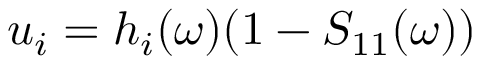Convert formula to latex. <formula><loc_0><loc_0><loc_500><loc_500>u _ { i } = h _ { i } ( \omega ) ( 1 - S _ { 1 1 } ( \omega ) )</formula> 